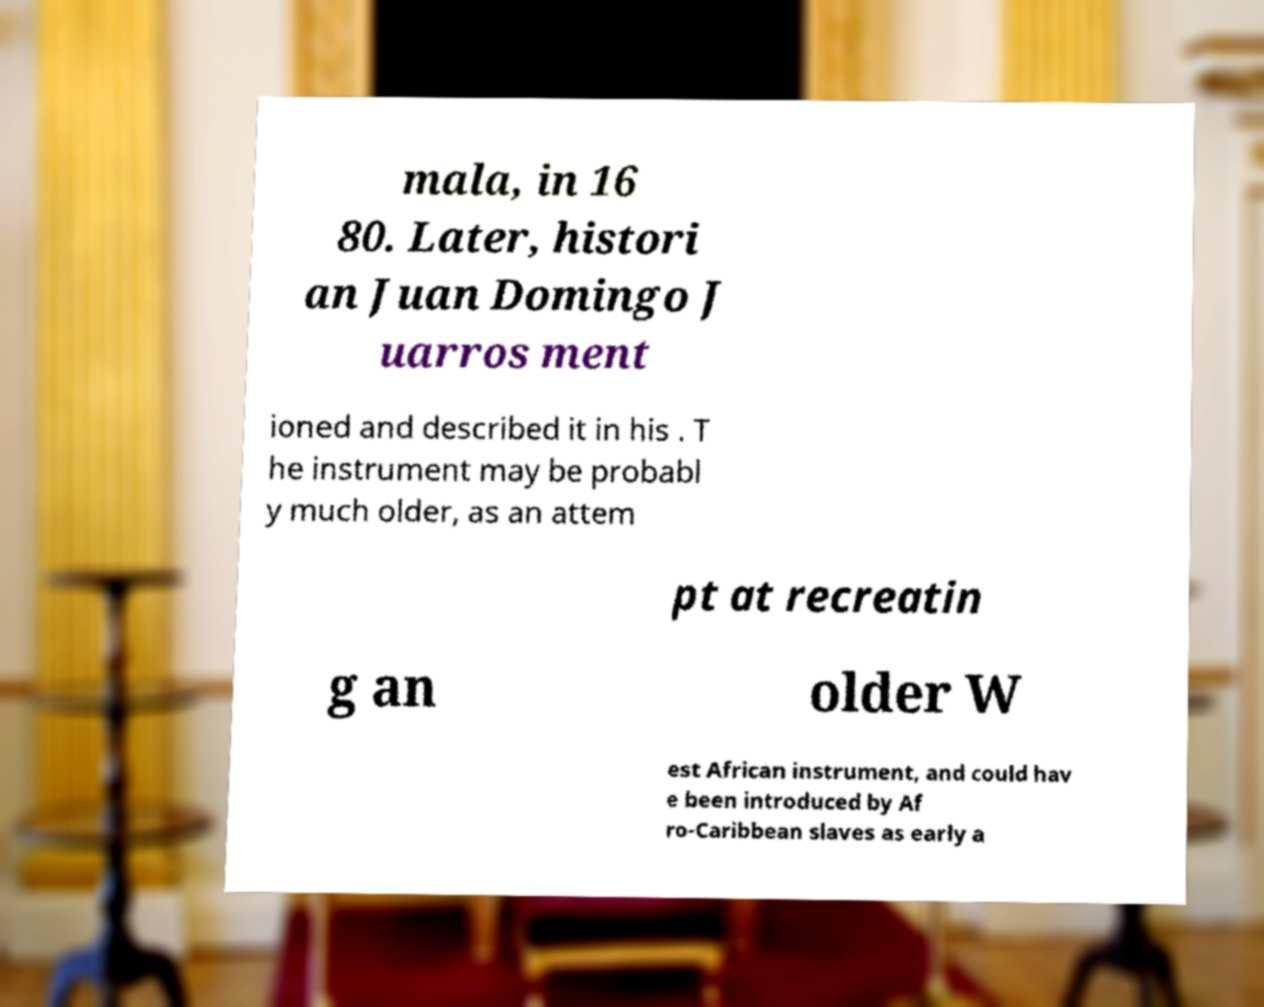I need the written content from this picture converted into text. Can you do that? mala, in 16 80. Later, histori an Juan Domingo J uarros ment ioned and described it in his . T he instrument may be probabl y much older, as an attem pt at recreatin g an older W est African instrument, and could hav e been introduced by Af ro-Caribbean slaves as early a 